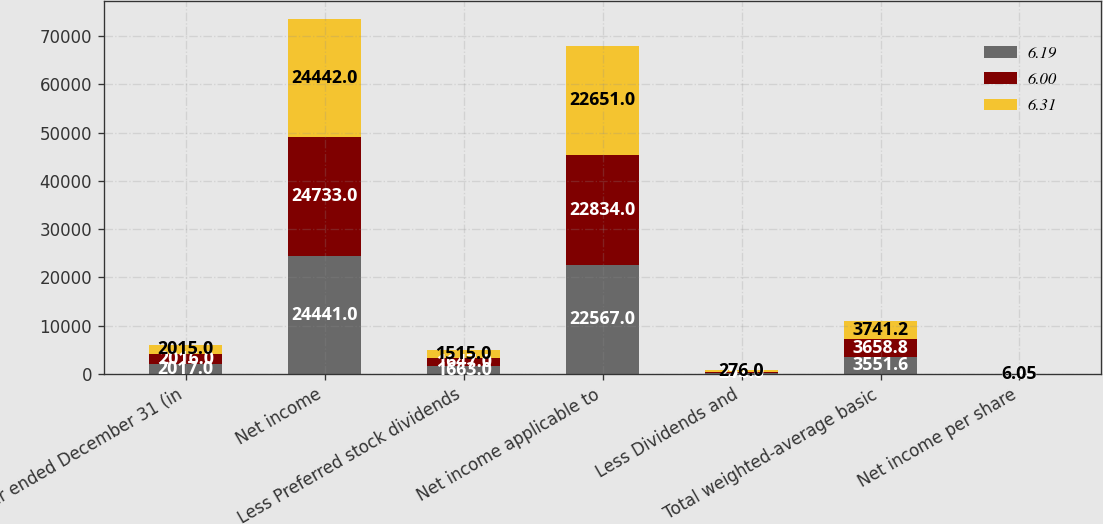Convert chart to OTSL. <chart><loc_0><loc_0><loc_500><loc_500><stacked_bar_chart><ecel><fcel>Year ended December 31 (in<fcel>Net income<fcel>Less Preferred stock dividends<fcel>Net income applicable to<fcel>Less Dividends and<fcel>Total weighted-average basic<fcel>Net income per share<nl><fcel>6.19<fcel>2017<fcel>24441<fcel>1663<fcel>22567<fcel>211<fcel>3551.6<fcel>6.35<nl><fcel>6<fcel>2016<fcel>24733<fcel>1647<fcel>22834<fcel>252<fcel>3658.8<fcel>6.24<nl><fcel>6.31<fcel>2015<fcel>24442<fcel>1515<fcel>22651<fcel>276<fcel>3741.2<fcel>6.05<nl></chart> 